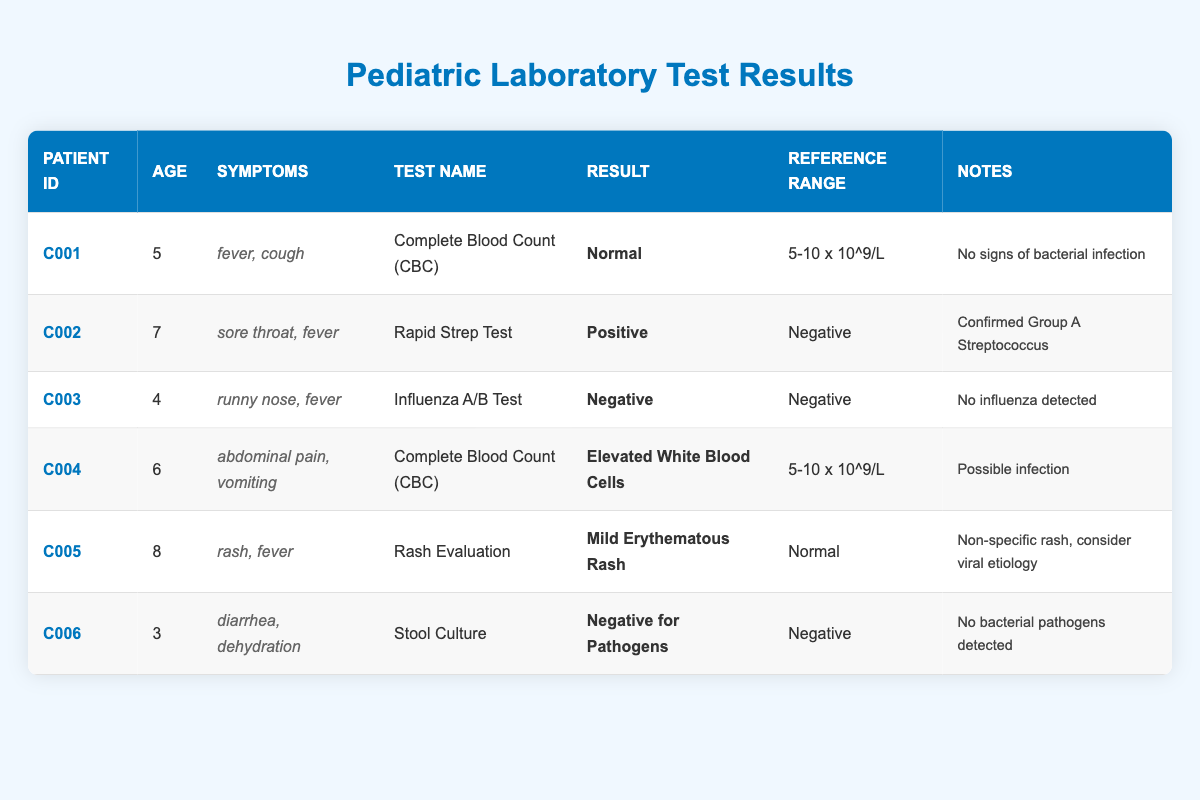What is the result of the Complete Blood Count test for patient C001? The table shows that patient C001 has a result value of "Normal" for the Complete Blood Count test, as indicated in the corresponding row of the table.
Answer: Normal Was the Influenza A/B test positive for patient C003? In the row for patient C003, the result value for the Influenza A/B Test is "Negative," which indicates that the test did not detect influenza.
Answer: No What are the common symptoms shared by patients C001 and C002? Looking at the symptoms for both patients, C001 has "fever, cough" and C002 has "sore throat, fever." The common symptom between them is "fever."
Answer: Fever How many patients tested negative for pathogens in their laboratory tests? By analyzing the table, we see that C003 and C006 have results of "Negative" for their respective tests (Influenza A/B Test for C003 and Stool Culture for C006). Thus, there are two patients who tested negative for pathogens.
Answer: 2 What is the age difference between the youngest and oldest patients in the table? The youngest patient is C006, aged 3, and the oldest patient is C005, aged 8. The age difference is 8 - 3 = 5 years.
Answer: 5 Is there a patient with elevated white blood cell count? The table indicates that patient C004 has "Elevated White Blood Cells" as the result for the Complete Blood Count test, which confirms that there is indeed a patient with this condition.
Answer: Yes How many patients displayed fever as a symptom? Counting the rows in the table, patients C001, C002, C003, C004, and C005 show "fever" as one of their symptoms. There are five patients in total who displayed fever.
Answer: 5 What percentage of patients tested positive for the Rapid Strep Test? There are six total patients, and only patient C002 tested positive for the Rapid Strep Test. The percentage is calculated as (1 positive / 6 total) * 100 = 16.67%.
Answer: 16.67% Which test confirmed Group A Streptococcus? Looking at the notes for patient C002, the Rapid Strep Test result is "Positive," and it is noted as confirmed for Group A Streptococcus.
Answer: Rapid Strep Test 